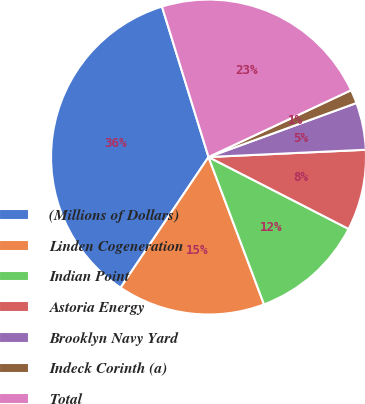<chart> <loc_0><loc_0><loc_500><loc_500><pie_chart><fcel>(Millions of Dollars)<fcel>Linden Cogeneration<fcel>Indian Point<fcel>Astoria Energy<fcel>Brooklyn Navy Yard<fcel>Indeck Corinth (a)<fcel>Total<nl><fcel>35.79%<fcel>15.16%<fcel>11.72%<fcel>8.28%<fcel>4.84%<fcel>1.4%<fcel>22.8%<nl></chart> 